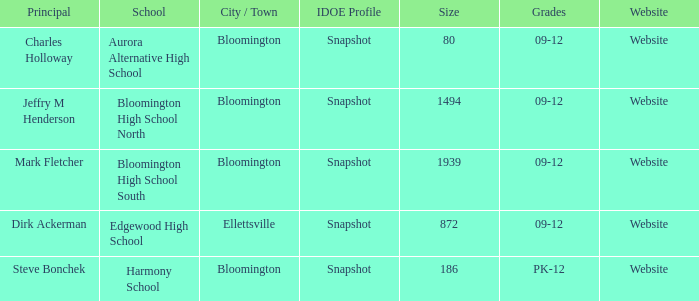Where's the school that Mark Fletcher is the principal of? Bloomington. 